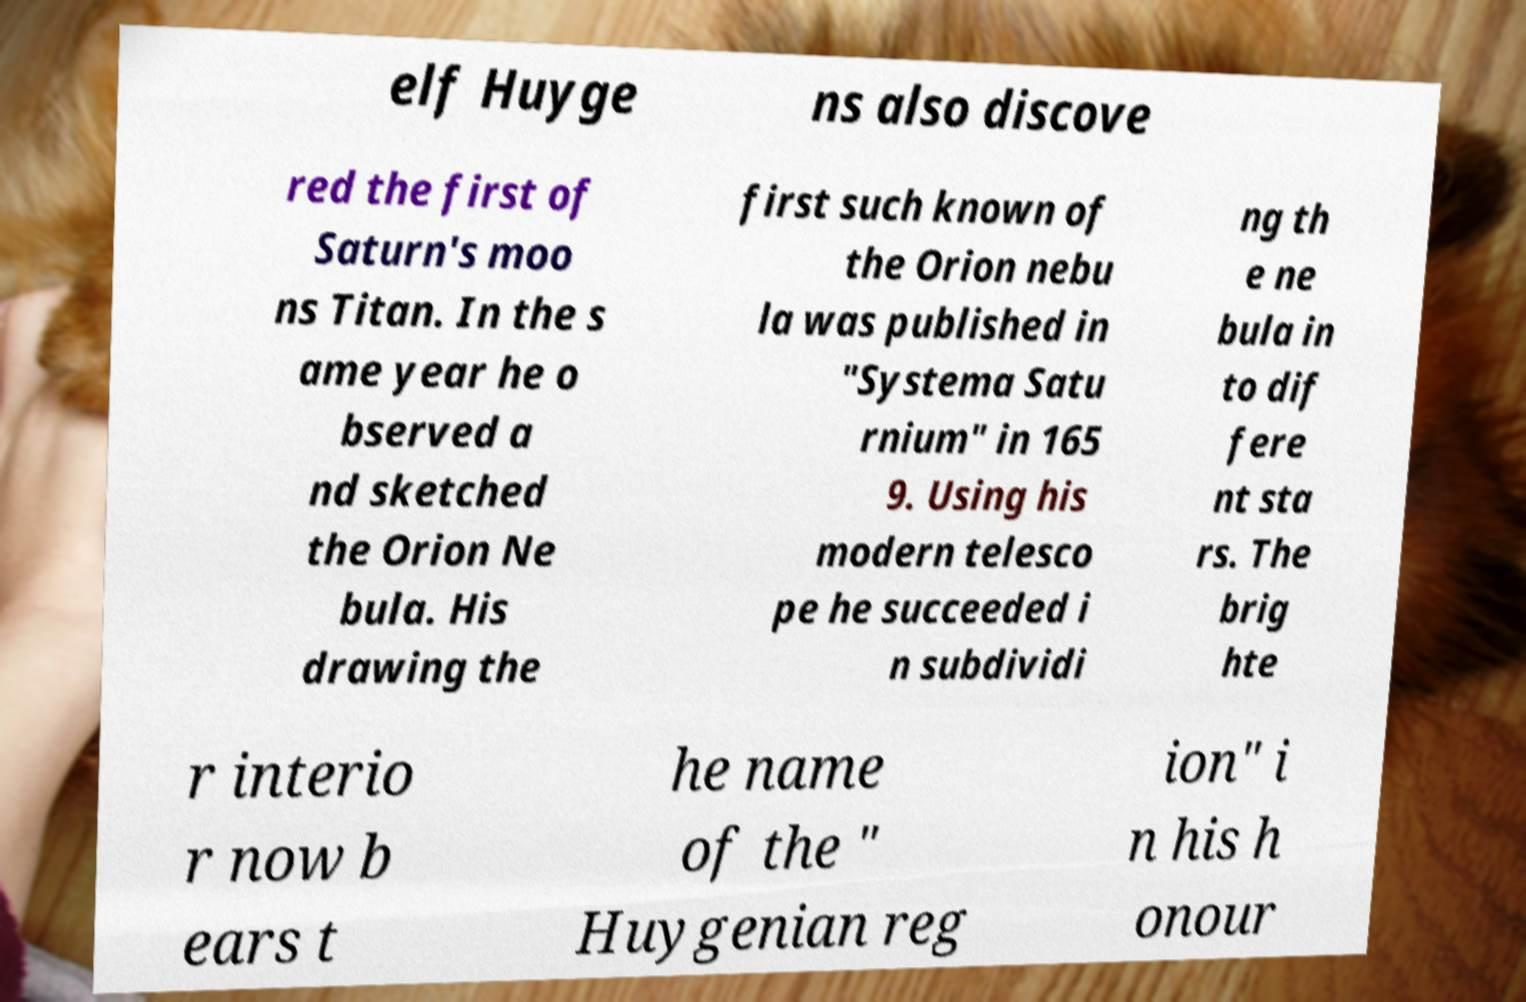There's text embedded in this image that I need extracted. Can you transcribe it verbatim? elf Huyge ns also discove red the first of Saturn's moo ns Titan. In the s ame year he o bserved a nd sketched the Orion Ne bula. His drawing the first such known of the Orion nebu la was published in "Systema Satu rnium" in 165 9. Using his modern telesco pe he succeeded i n subdividi ng th e ne bula in to dif fere nt sta rs. The brig hte r interio r now b ears t he name of the " Huygenian reg ion" i n his h onour 